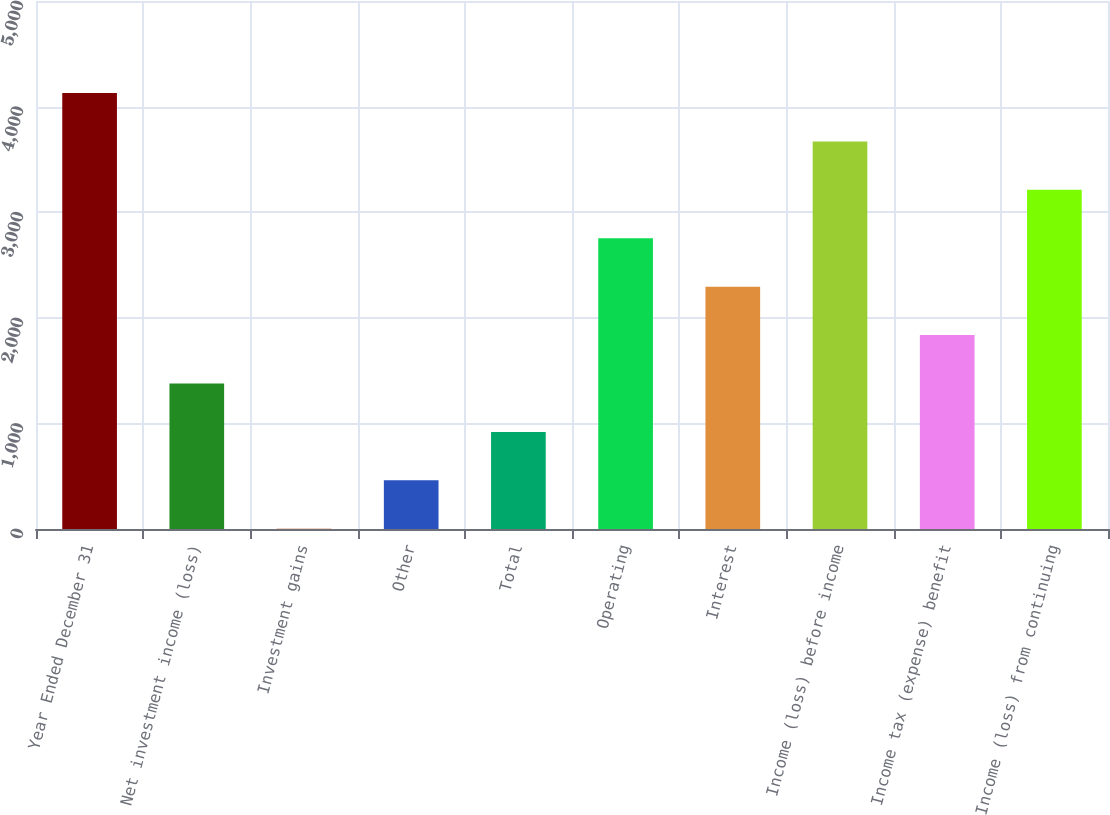<chart> <loc_0><loc_0><loc_500><loc_500><bar_chart><fcel>Year Ended December 31<fcel>Net investment income (loss)<fcel>Investment gains<fcel>Other<fcel>Total<fcel>Operating<fcel>Interest<fcel>Income (loss) before income<fcel>Income tax (expense) benefit<fcel>Income (loss) from continuing<nl><fcel>4128.5<fcel>1377.5<fcel>2<fcel>460.5<fcel>919<fcel>2753<fcel>2294.5<fcel>3670<fcel>1836<fcel>3211.5<nl></chart> 